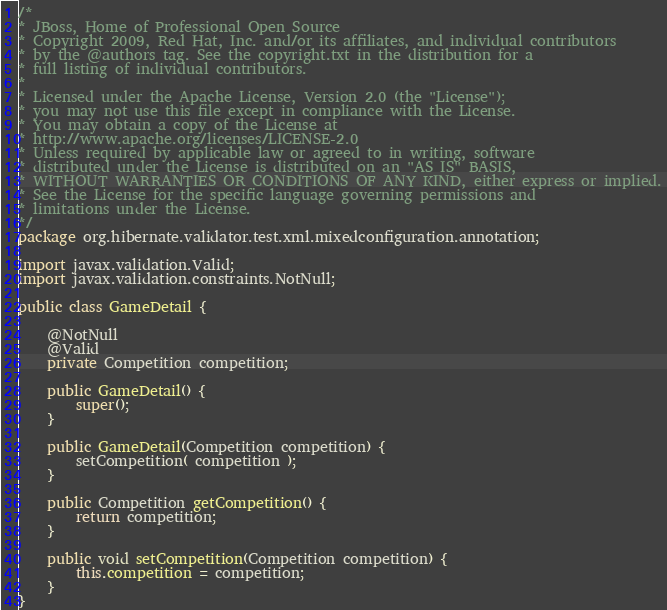Convert code to text. <code><loc_0><loc_0><loc_500><loc_500><_Java_>/*
* JBoss, Home of Professional Open Source
* Copyright 2009, Red Hat, Inc. and/or its affiliates, and individual contributors
* by the @authors tag. See the copyright.txt in the distribution for a
* full listing of individual contributors.
*
* Licensed under the Apache License, Version 2.0 (the "License");
* you may not use this file except in compliance with the License.
* You may obtain a copy of the License at
* http://www.apache.org/licenses/LICENSE-2.0
* Unless required by applicable law or agreed to in writing, software
* distributed under the License is distributed on an "AS IS" BASIS,
* WITHOUT WARRANTIES OR CONDITIONS OF ANY KIND, either express or implied.
* See the License for the specific language governing permissions and
* limitations under the License.
*/
package org.hibernate.validator.test.xml.mixedconfiguration.annotation;

import javax.validation.Valid;
import javax.validation.constraints.NotNull;

public class GameDetail {

	@NotNull
	@Valid
	private Competition competition;

	public GameDetail() {
		super();
	}

	public GameDetail(Competition competition) {
		setCompetition( competition );
	}

	public Competition getCompetition() {
		return competition;
	}

	public void setCompetition(Competition competition) {
		this.competition = competition;
	}
}
</code> 